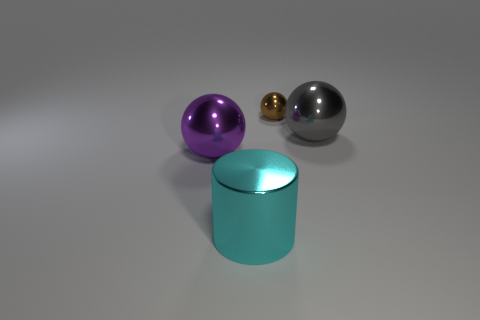There is a thing on the right side of the tiny brown metal object; what is its shape?
Offer a very short reply. Sphere. How big is the ball in front of the large metallic sphere right of the sphere on the left side of the brown shiny ball?
Your answer should be compact. Large. Does the brown object have the same shape as the large purple object?
Offer a terse response. Yes. What size is the object that is left of the small brown sphere and right of the large purple metallic thing?
Your answer should be very brief. Large. There is a cyan shiny thing; does it have the same shape as the metallic object behind the gray thing?
Your answer should be very brief. No. How many metal objects are either large gray things or tiny brown balls?
Offer a terse response. 2. There is a large shiny object to the left of the large shiny object in front of the metallic ball that is in front of the large gray shiny object; what is its color?
Keep it short and to the point. Purple. How many other things are made of the same material as the cylinder?
Provide a succinct answer. 3. There is a big object that is on the right side of the cylinder; does it have the same shape as the small brown metallic object?
Provide a succinct answer. Yes. How many small things are either cylinders or cyan balls?
Keep it short and to the point. 0. 